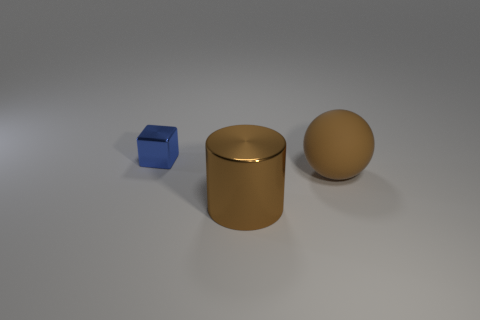Add 1 tiny green objects. How many objects exist? 4 Subtract all brown cylinders. How many red spheres are left? 0 Subtract all small gray metal cylinders. Subtract all brown metal objects. How many objects are left? 2 Add 1 tiny metal things. How many tiny metal things are left? 2 Add 2 brown matte things. How many brown matte things exist? 3 Subtract 1 brown spheres. How many objects are left? 2 Subtract all cylinders. How many objects are left? 2 Subtract all yellow balls. Subtract all purple cylinders. How many balls are left? 1 